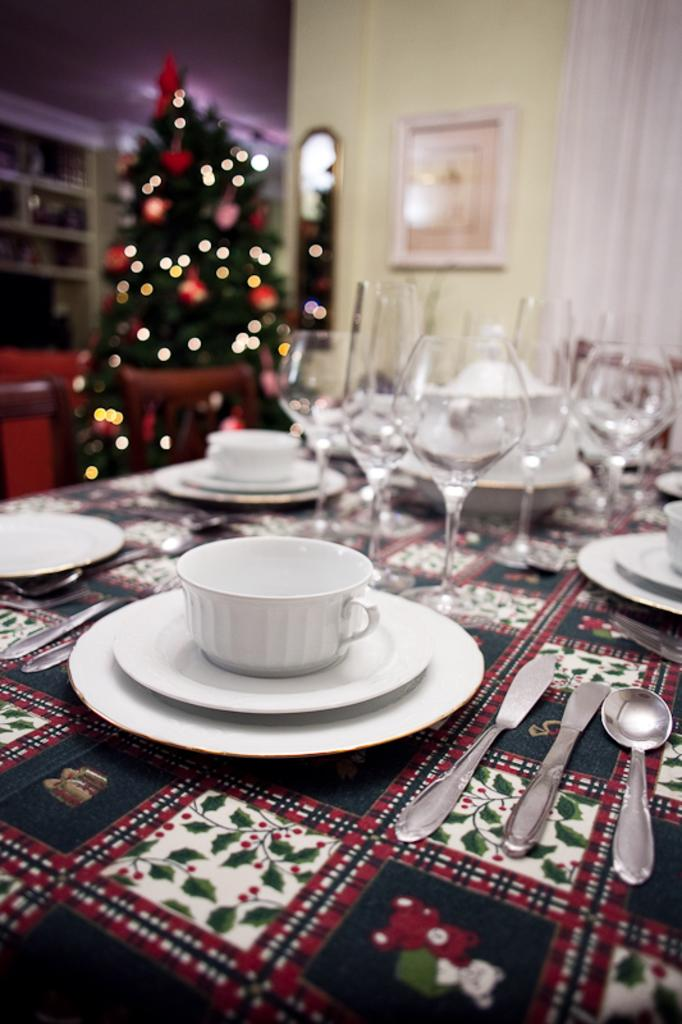What type of glassware is present in the image? There are wine glasses and tea cups in the image. What other tableware can be seen in the image? There are plates, spoons, and knives in the image. Where are these objects located? The objects are on a table. What additional element is present in the image? There is a Christmas tree in the image. What is hanging on the wall in the image? There is a photo frame on the wall. What advice is given in the image regarding the upcoming battle? There is no mention of a battle or any advice in the image; it primarily features tableware, a Christmas tree, and a photo frame. 